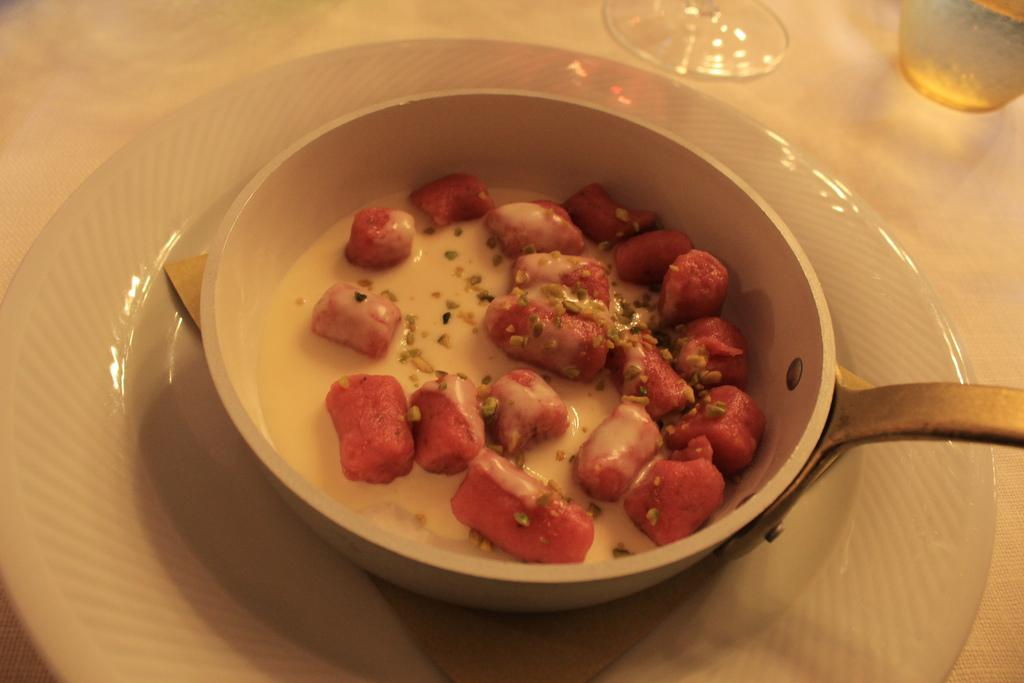What is being cooked in the small fry pan in the image? There is a food item in a small fry pan in the image, but the specific food item is not mentioned. How is the fry pan positioned in the image? The fry pan is on a plate in the image. What can be seen in the background of the image? There are objects on a table in the background of the image. How does the team adjust the bag in the image? There is no team, bag, or any adjustment activity present in the image. 